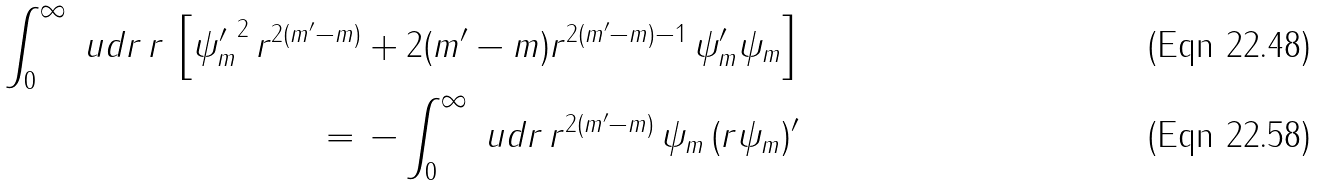<formula> <loc_0><loc_0><loc_500><loc_500>\int _ { 0 } ^ { \infty } \ u d r \, r \, \left [ { \psi _ { m } ^ { \prime } } ^ { 2 } \, r ^ { 2 ( m ^ { \prime } - m ) } + 2 ( m ^ { \prime } - m ) r ^ { 2 ( m ^ { \prime } - m ) - 1 } \, \psi _ { m } ^ { \prime } \psi _ { m } \right ] \\ = \, - \int _ { 0 } ^ { \infty } \ u d r \, r ^ { 2 ( m ^ { \prime } - m ) } \, \psi _ { m } \, ( r \psi _ { m } ) ^ { \prime }</formula> 